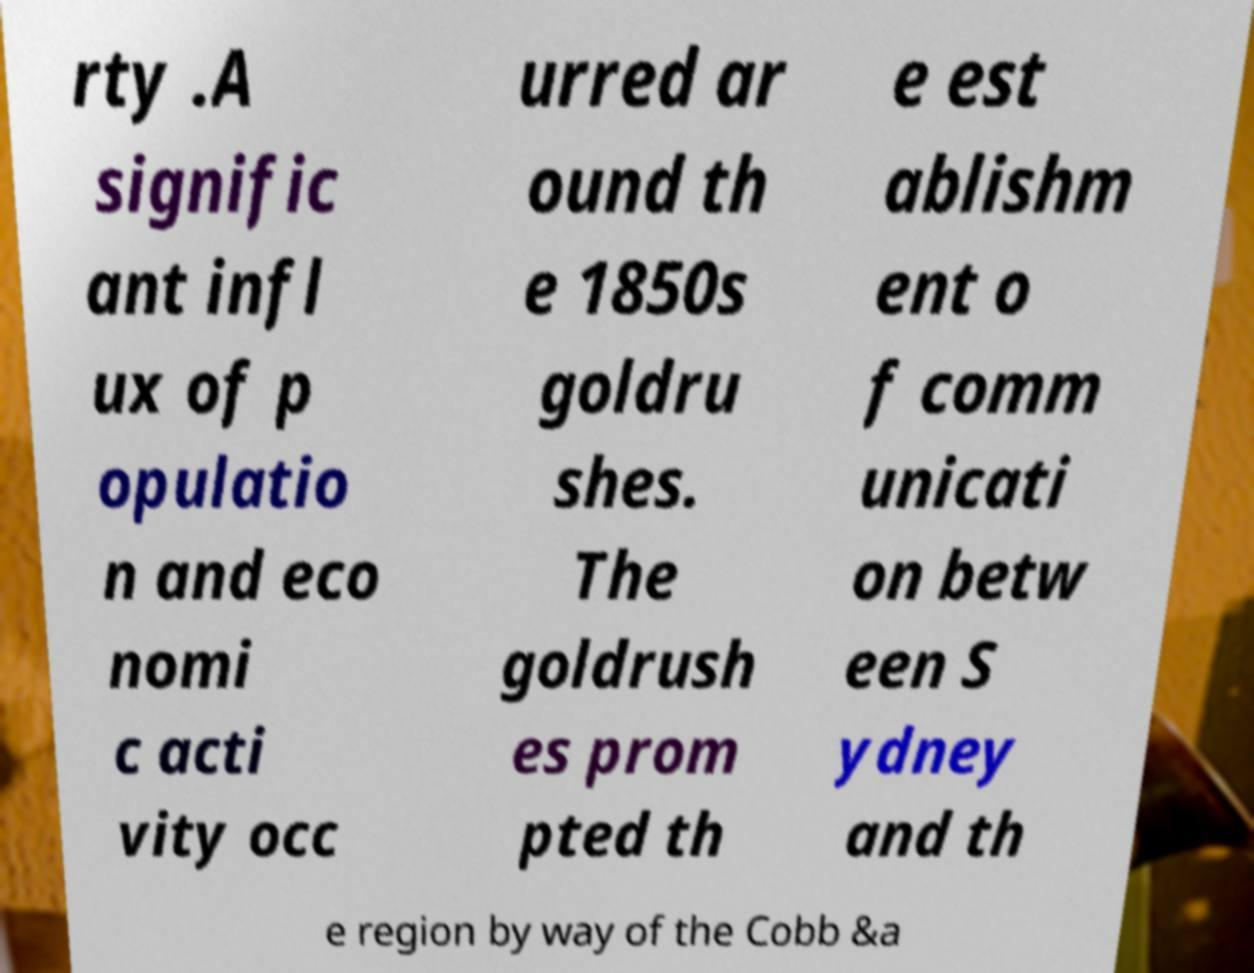For documentation purposes, I need the text within this image transcribed. Could you provide that? rty .A signific ant infl ux of p opulatio n and eco nomi c acti vity occ urred ar ound th e 1850s goldru shes. The goldrush es prom pted th e est ablishm ent o f comm unicati on betw een S ydney and th e region by way of the Cobb &a 